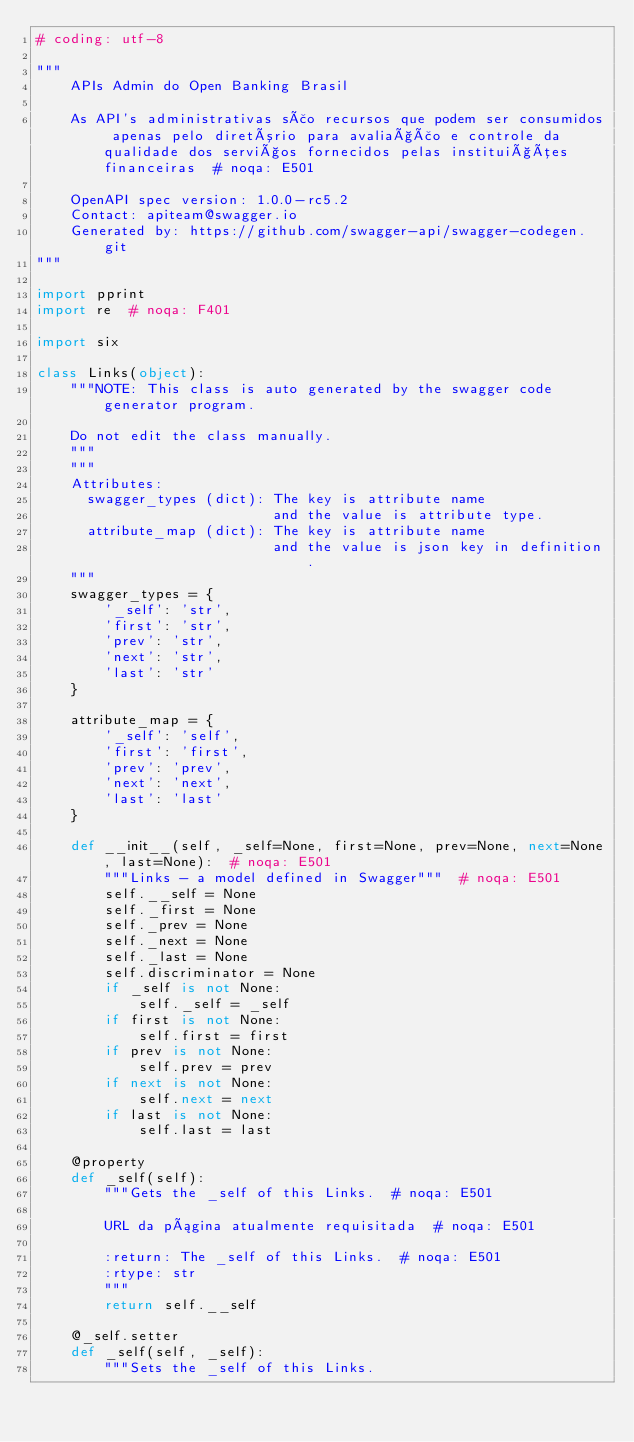Convert code to text. <code><loc_0><loc_0><loc_500><loc_500><_Python_># coding: utf-8

"""
    APIs Admin do Open Banking Brasil

    As API's administrativas são recursos que podem ser consumidos apenas pelo diretório para avaliação e controle da qualidade dos serviços fornecidos pelas instituições financeiras  # noqa: E501

    OpenAPI spec version: 1.0.0-rc5.2
    Contact: apiteam@swagger.io
    Generated by: https://github.com/swagger-api/swagger-codegen.git
"""

import pprint
import re  # noqa: F401

import six

class Links(object):
    """NOTE: This class is auto generated by the swagger code generator program.

    Do not edit the class manually.
    """
    """
    Attributes:
      swagger_types (dict): The key is attribute name
                            and the value is attribute type.
      attribute_map (dict): The key is attribute name
                            and the value is json key in definition.
    """
    swagger_types = {
        '_self': 'str',
        'first': 'str',
        'prev': 'str',
        'next': 'str',
        'last': 'str'
    }

    attribute_map = {
        '_self': 'self',
        'first': 'first',
        'prev': 'prev',
        'next': 'next',
        'last': 'last'
    }

    def __init__(self, _self=None, first=None, prev=None, next=None, last=None):  # noqa: E501
        """Links - a model defined in Swagger"""  # noqa: E501
        self.__self = None
        self._first = None
        self._prev = None
        self._next = None
        self._last = None
        self.discriminator = None
        if _self is not None:
            self._self = _self
        if first is not None:
            self.first = first
        if prev is not None:
            self.prev = prev
        if next is not None:
            self.next = next
        if last is not None:
            self.last = last

    @property
    def _self(self):
        """Gets the _self of this Links.  # noqa: E501

        URL da página atualmente requisitada  # noqa: E501

        :return: The _self of this Links.  # noqa: E501
        :rtype: str
        """
        return self.__self

    @_self.setter
    def _self(self, _self):
        """Sets the _self of this Links.
</code> 